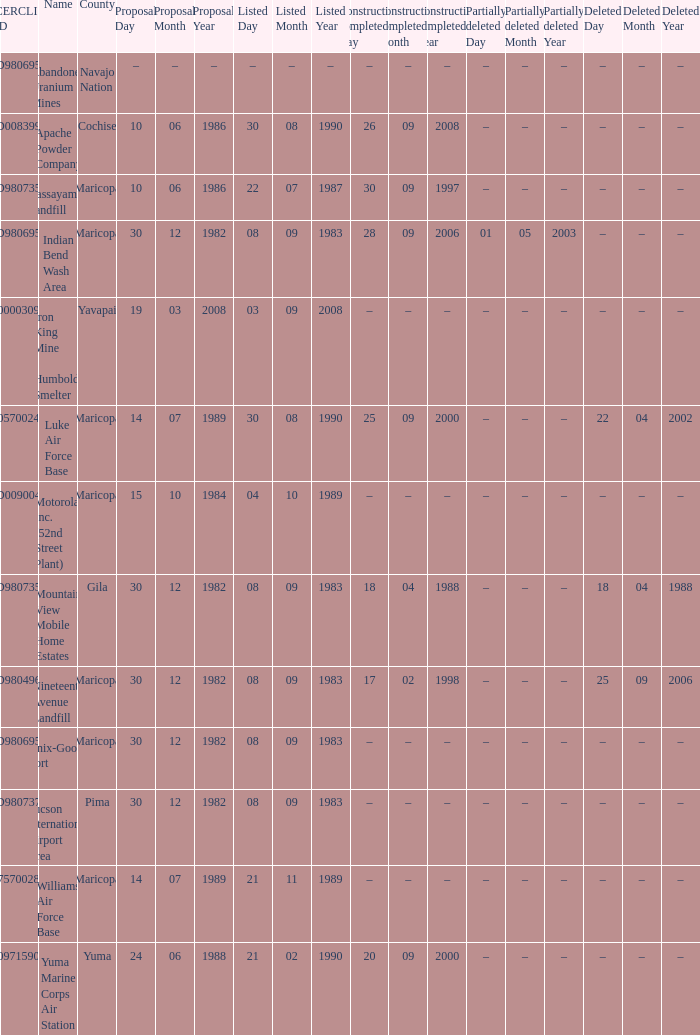When was the site listed when the county is cochise? 08/30/1990. 